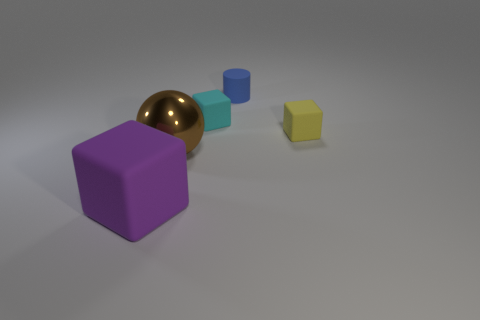Add 5 yellow blocks. How many objects exist? 10 Subtract all small yellow rubber cubes. How many cubes are left? 2 Subtract all brown cylinders. How many purple cubes are left? 1 Subtract all tiny blue cylinders. Subtract all small cyan things. How many objects are left? 3 Add 5 big blocks. How many big blocks are left? 6 Add 4 yellow rubber cubes. How many yellow rubber cubes exist? 5 Subtract all purple cubes. How many cubes are left? 2 Subtract 0 cyan cylinders. How many objects are left? 5 Subtract all balls. How many objects are left? 4 Subtract all cyan cubes. Subtract all gray cylinders. How many cubes are left? 2 